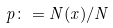<formula> <loc_0><loc_0><loc_500><loc_500>p \colon = N ( x ) / N</formula> 